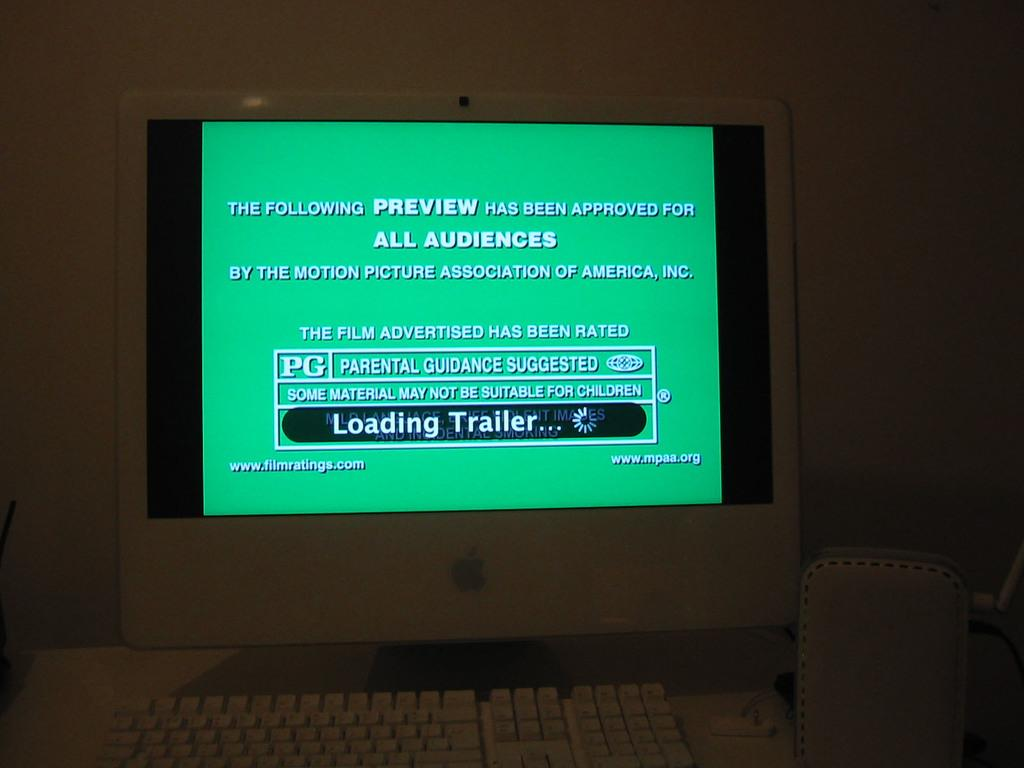<image>
Summarize the visual content of the image. An apple monitor on display with a buffering loading trailer alert. 